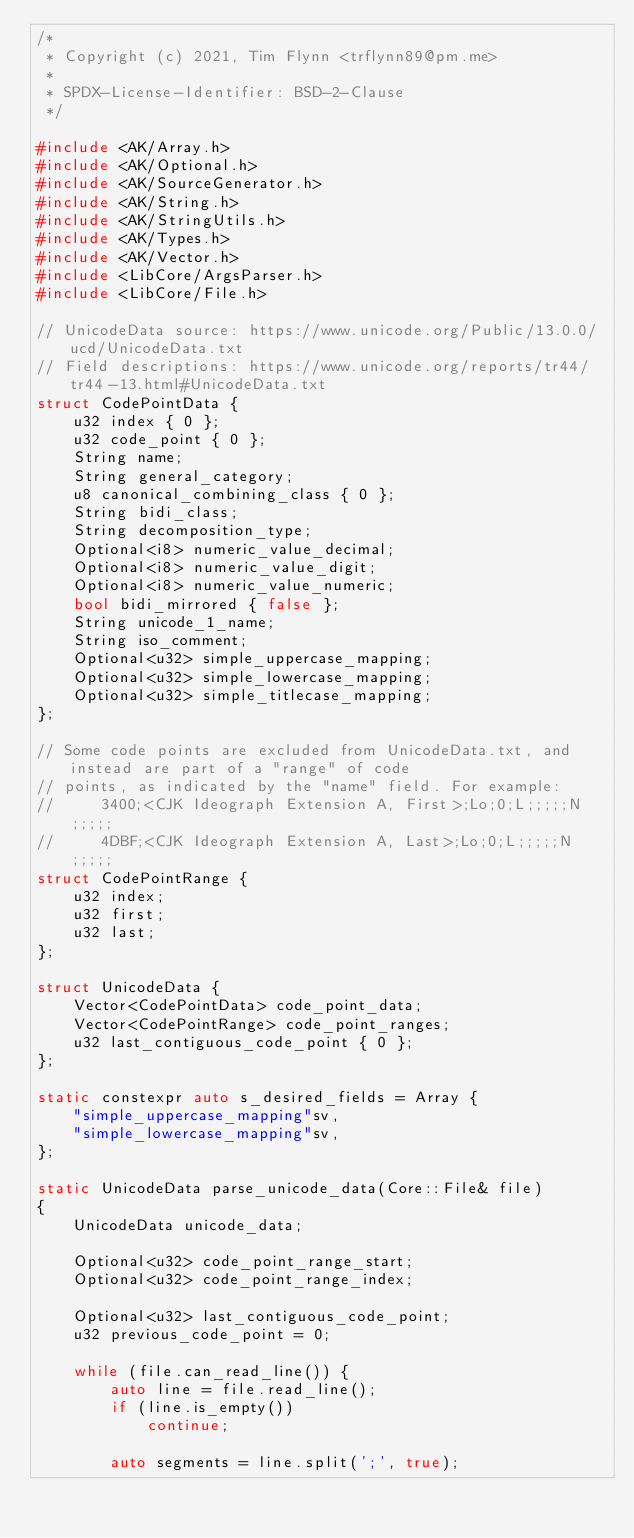Convert code to text. <code><loc_0><loc_0><loc_500><loc_500><_C++_>/*
 * Copyright (c) 2021, Tim Flynn <trflynn89@pm.me>
 *
 * SPDX-License-Identifier: BSD-2-Clause
 */

#include <AK/Array.h>
#include <AK/Optional.h>
#include <AK/SourceGenerator.h>
#include <AK/String.h>
#include <AK/StringUtils.h>
#include <AK/Types.h>
#include <AK/Vector.h>
#include <LibCore/ArgsParser.h>
#include <LibCore/File.h>

// UnicodeData source: https://www.unicode.org/Public/13.0.0/ucd/UnicodeData.txt
// Field descriptions: https://www.unicode.org/reports/tr44/tr44-13.html#UnicodeData.txt
struct CodePointData {
    u32 index { 0 };
    u32 code_point { 0 };
    String name;
    String general_category;
    u8 canonical_combining_class { 0 };
    String bidi_class;
    String decomposition_type;
    Optional<i8> numeric_value_decimal;
    Optional<i8> numeric_value_digit;
    Optional<i8> numeric_value_numeric;
    bool bidi_mirrored { false };
    String unicode_1_name;
    String iso_comment;
    Optional<u32> simple_uppercase_mapping;
    Optional<u32> simple_lowercase_mapping;
    Optional<u32> simple_titlecase_mapping;
};

// Some code points are excluded from UnicodeData.txt, and instead are part of a "range" of code
// points, as indicated by the "name" field. For example:
//     3400;<CJK Ideograph Extension A, First>;Lo;0;L;;;;;N;;;;;
//     4DBF;<CJK Ideograph Extension A, Last>;Lo;0;L;;;;;N;;;;;
struct CodePointRange {
    u32 index;
    u32 first;
    u32 last;
};

struct UnicodeData {
    Vector<CodePointData> code_point_data;
    Vector<CodePointRange> code_point_ranges;
    u32 last_contiguous_code_point { 0 };
};

static constexpr auto s_desired_fields = Array {
    "simple_uppercase_mapping"sv,
    "simple_lowercase_mapping"sv,
};

static UnicodeData parse_unicode_data(Core::File& file)
{
    UnicodeData unicode_data;

    Optional<u32> code_point_range_start;
    Optional<u32> code_point_range_index;

    Optional<u32> last_contiguous_code_point;
    u32 previous_code_point = 0;

    while (file.can_read_line()) {
        auto line = file.read_line();
        if (line.is_empty())
            continue;

        auto segments = line.split(';', true);</code> 